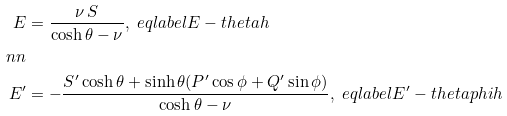<formula> <loc_0><loc_0><loc_500><loc_500>E & = \frac { \nu \, S } { \cosh \theta - \nu } , \ e q l a b e l { E - t h e t a h } \\ \ n n \\ E ^ { \prime } & = - \frac { S ^ { \prime } \cosh \theta + \sinh \theta ( P ^ { \prime } \cos \phi + Q ^ { \prime } \sin \phi ) } { \cosh \theta - \nu } , \ e q l a b e l { E ^ { \prime } - t h e t a p h i h }</formula> 